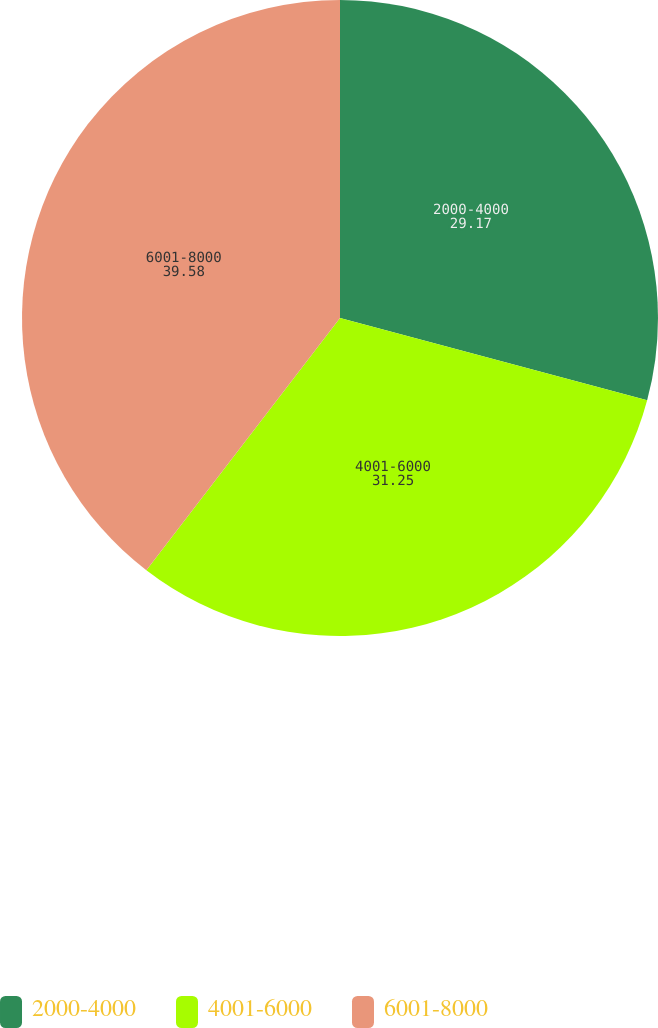<chart> <loc_0><loc_0><loc_500><loc_500><pie_chart><fcel>2000-4000<fcel>4001-6000<fcel>6001-8000<nl><fcel>29.17%<fcel>31.25%<fcel>39.58%<nl></chart> 